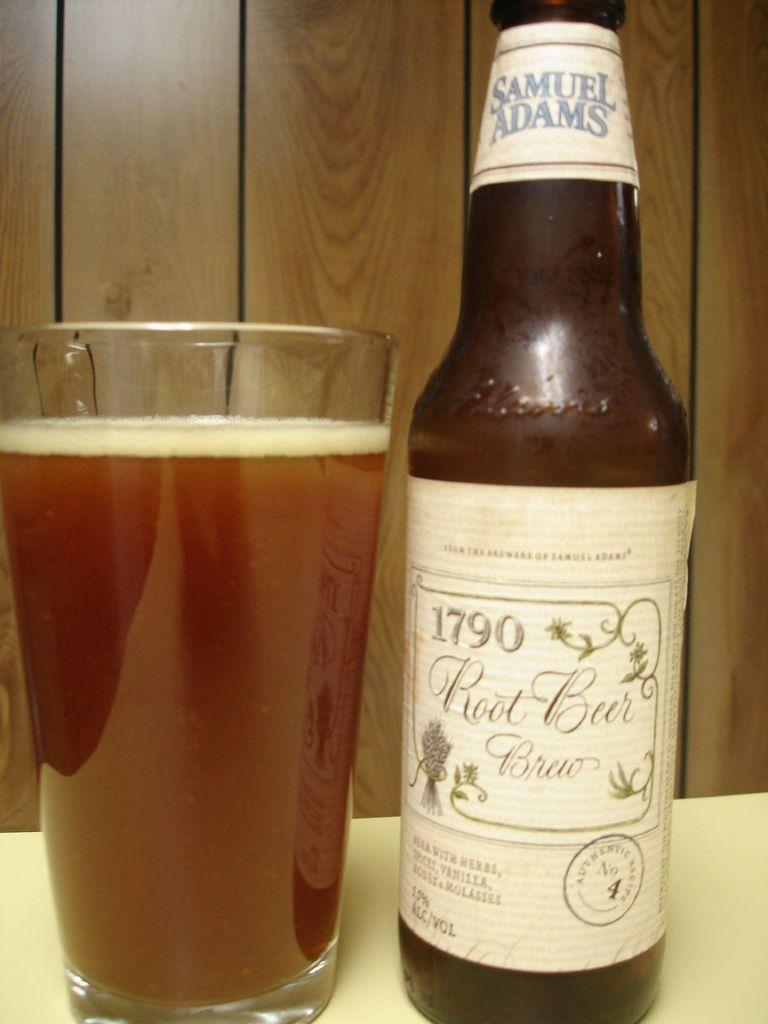<image>
Present a compact description of the photo's key features. The beer pictured comes from an authentic receipe. 